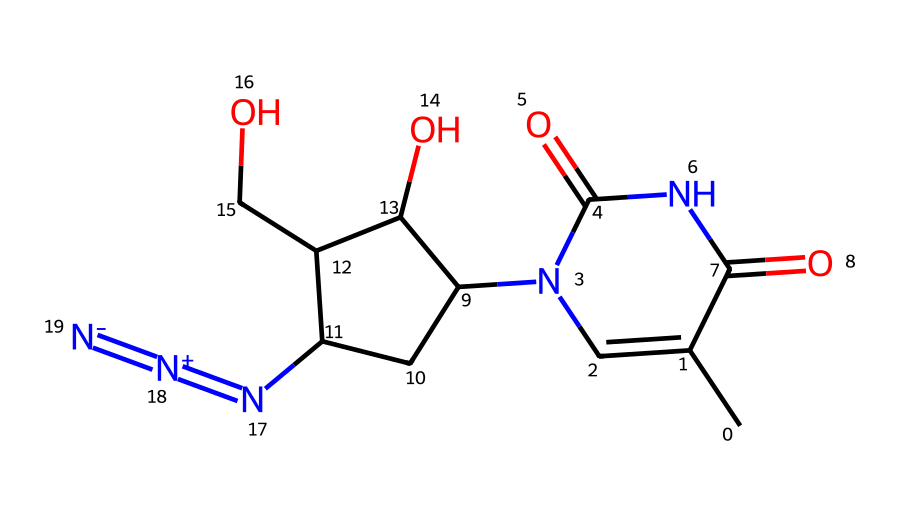What is the molecular formula of azidothymidine (AZT)? To determine the molecular formula, count the individual types of atoms represented in the SMILES. There are 10 carbon atoms (C), 13 hydrogen atoms (H), 5 nitrogen atoms (N), and 3 oxygen atoms (O). Combining these gives the molecular formula C10H13N5O3.
Answer: C10H13N5O3 How many nitrogen atoms are present in this structure? The SMILES representation includes the notation for nitrogen (N) in multiple places, specifically in the azide group, indicating 5 nitrogen atoms when counted.
Answer: 5 What type of functional groups are present in azidothymidine? Analyzing the SMILES shows the presence of an azide group (N=N=), carbonyl groups (C=O), and hydroxyl groups (C-OH), indicating multiple functional groups including azides, carbonyls, and alcohols.
Answer: azides, carbonyls, alcohols What is the hybridization of the nitrogen atoms in the azide group? The azide group consists of nitrogen atoms connected in a linear arrangement (N=N=N), indicating sp hybridization due to the triple bond between the first two nitrogen atoms. The geometry is linear, characteristic of sp hybridization.
Answer: sp Is azidothymidine an antiviral drug? The context and knowledge about AZT indicates its primary use are in HIV treatment, making it classified as an antiviral drug.
Answer: Yes How does the presence of the azide group affect the reactivity of azidothymidine? The azide group is known for its high reactivity due to the presence of three nitrogen atoms, which makes it a better candidate for substitution reactions, enhancing its effectiveness in entering cells and inhibiting viral replication.
Answer: Increases reactivity 